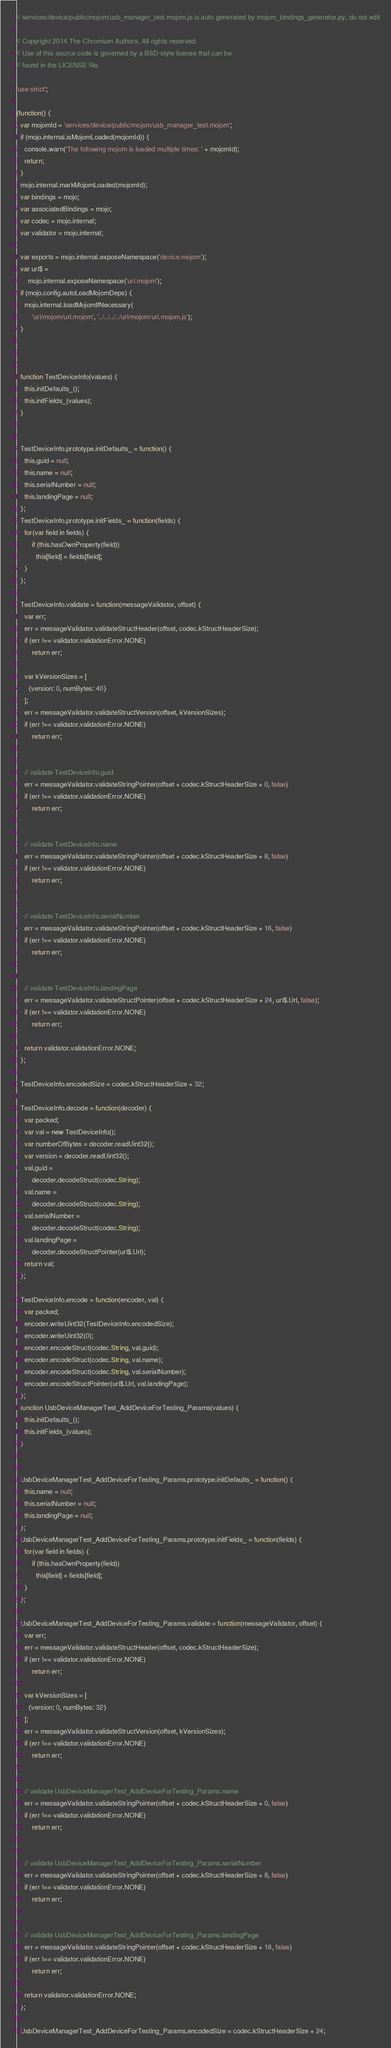Convert code to text. <code><loc_0><loc_0><loc_500><loc_500><_JavaScript_>// services/device/public/mojom/usb_manager_test.mojom.js is auto generated by mojom_bindings_generator.py, do not edit

// Copyright 2014 The Chromium Authors. All rights reserved.
// Use of this source code is governed by a BSD-style license that can be
// found in the LICENSE file.

'use strict';

(function() {
  var mojomId = 'services/device/public/mojom/usb_manager_test.mojom';
  if (mojo.internal.isMojomLoaded(mojomId)) {
    console.warn('The following mojom is loaded multiple times: ' + mojomId);
    return;
  }
  mojo.internal.markMojomLoaded(mojomId);
  var bindings = mojo;
  var associatedBindings = mojo;
  var codec = mojo.internal;
  var validator = mojo.internal;

  var exports = mojo.internal.exposeNamespace('device.mojom');
  var url$ =
      mojo.internal.exposeNamespace('url.mojom');
  if (mojo.config.autoLoadMojomDeps) {
    mojo.internal.loadMojomIfNecessary(
        'url/mojom/url.mojom', '../../../../url/mojom/url.mojom.js');
  }



  function TestDeviceInfo(values) {
    this.initDefaults_();
    this.initFields_(values);
  }


  TestDeviceInfo.prototype.initDefaults_ = function() {
    this.guid = null;
    this.name = null;
    this.serialNumber = null;
    this.landingPage = null;
  };
  TestDeviceInfo.prototype.initFields_ = function(fields) {
    for(var field in fields) {
        if (this.hasOwnProperty(field))
          this[field] = fields[field];
    }
  };

  TestDeviceInfo.validate = function(messageValidator, offset) {
    var err;
    err = messageValidator.validateStructHeader(offset, codec.kStructHeaderSize);
    if (err !== validator.validationError.NONE)
        return err;

    var kVersionSizes = [
      {version: 0, numBytes: 40}
    ];
    err = messageValidator.validateStructVersion(offset, kVersionSizes);
    if (err !== validator.validationError.NONE)
        return err;


    // validate TestDeviceInfo.guid
    err = messageValidator.validateStringPointer(offset + codec.kStructHeaderSize + 0, false)
    if (err !== validator.validationError.NONE)
        return err;


    // validate TestDeviceInfo.name
    err = messageValidator.validateStringPointer(offset + codec.kStructHeaderSize + 8, false)
    if (err !== validator.validationError.NONE)
        return err;


    // validate TestDeviceInfo.serialNumber
    err = messageValidator.validateStringPointer(offset + codec.kStructHeaderSize + 16, false)
    if (err !== validator.validationError.NONE)
        return err;


    // validate TestDeviceInfo.landingPage
    err = messageValidator.validateStructPointer(offset + codec.kStructHeaderSize + 24, url$.Url, false);
    if (err !== validator.validationError.NONE)
        return err;

    return validator.validationError.NONE;
  };

  TestDeviceInfo.encodedSize = codec.kStructHeaderSize + 32;

  TestDeviceInfo.decode = function(decoder) {
    var packed;
    var val = new TestDeviceInfo();
    var numberOfBytes = decoder.readUint32();
    var version = decoder.readUint32();
    val.guid =
        decoder.decodeStruct(codec.String);
    val.name =
        decoder.decodeStruct(codec.String);
    val.serialNumber =
        decoder.decodeStruct(codec.String);
    val.landingPage =
        decoder.decodeStructPointer(url$.Url);
    return val;
  };

  TestDeviceInfo.encode = function(encoder, val) {
    var packed;
    encoder.writeUint32(TestDeviceInfo.encodedSize);
    encoder.writeUint32(0);
    encoder.encodeStruct(codec.String, val.guid);
    encoder.encodeStruct(codec.String, val.name);
    encoder.encodeStruct(codec.String, val.serialNumber);
    encoder.encodeStructPointer(url$.Url, val.landingPage);
  };
  function UsbDeviceManagerTest_AddDeviceForTesting_Params(values) {
    this.initDefaults_();
    this.initFields_(values);
  }


  UsbDeviceManagerTest_AddDeviceForTesting_Params.prototype.initDefaults_ = function() {
    this.name = null;
    this.serialNumber = null;
    this.landingPage = null;
  };
  UsbDeviceManagerTest_AddDeviceForTesting_Params.prototype.initFields_ = function(fields) {
    for(var field in fields) {
        if (this.hasOwnProperty(field))
          this[field] = fields[field];
    }
  };

  UsbDeviceManagerTest_AddDeviceForTesting_Params.validate = function(messageValidator, offset) {
    var err;
    err = messageValidator.validateStructHeader(offset, codec.kStructHeaderSize);
    if (err !== validator.validationError.NONE)
        return err;

    var kVersionSizes = [
      {version: 0, numBytes: 32}
    ];
    err = messageValidator.validateStructVersion(offset, kVersionSizes);
    if (err !== validator.validationError.NONE)
        return err;


    // validate UsbDeviceManagerTest_AddDeviceForTesting_Params.name
    err = messageValidator.validateStringPointer(offset + codec.kStructHeaderSize + 0, false)
    if (err !== validator.validationError.NONE)
        return err;


    // validate UsbDeviceManagerTest_AddDeviceForTesting_Params.serialNumber
    err = messageValidator.validateStringPointer(offset + codec.kStructHeaderSize + 8, false)
    if (err !== validator.validationError.NONE)
        return err;


    // validate UsbDeviceManagerTest_AddDeviceForTesting_Params.landingPage
    err = messageValidator.validateStringPointer(offset + codec.kStructHeaderSize + 16, false)
    if (err !== validator.validationError.NONE)
        return err;

    return validator.validationError.NONE;
  };

  UsbDeviceManagerTest_AddDeviceForTesting_Params.encodedSize = codec.kStructHeaderSize + 24;
</code> 